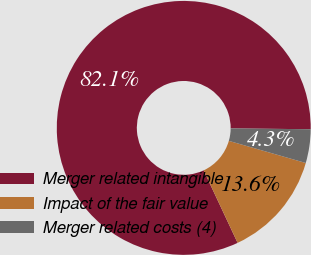Convert chart. <chart><loc_0><loc_0><loc_500><loc_500><pie_chart><fcel>Merger related intangible<fcel>Impact of the fair value<fcel>Merger related costs (4)<nl><fcel>82.14%<fcel>13.57%<fcel>4.29%<nl></chart> 